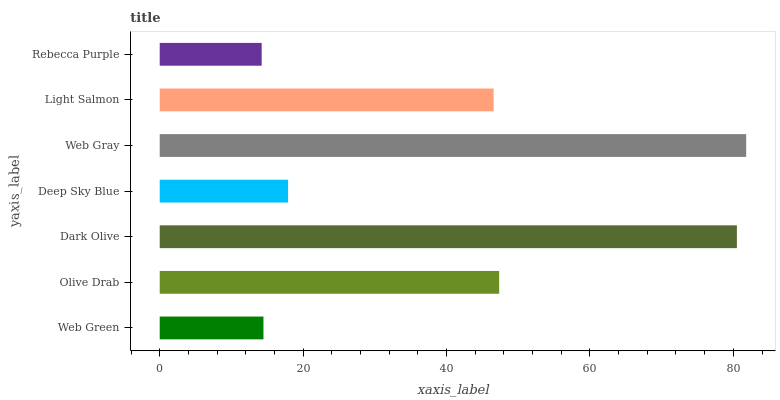Is Rebecca Purple the minimum?
Answer yes or no. Yes. Is Web Gray the maximum?
Answer yes or no. Yes. Is Olive Drab the minimum?
Answer yes or no. No. Is Olive Drab the maximum?
Answer yes or no. No. Is Olive Drab greater than Web Green?
Answer yes or no. Yes. Is Web Green less than Olive Drab?
Answer yes or no. Yes. Is Web Green greater than Olive Drab?
Answer yes or no. No. Is Olive Drab less than Web Green?
Answer yes or no. No. Is Light Salmon the high median?
Answer yes or no. Yes. Is Light Salmon the low median?
Answer yes or no. Yes. Is Deep Sky Blue the high median?
Answer yes or no. No. Is Deep Sky Blue the low median?
Answer yes or no. No. 